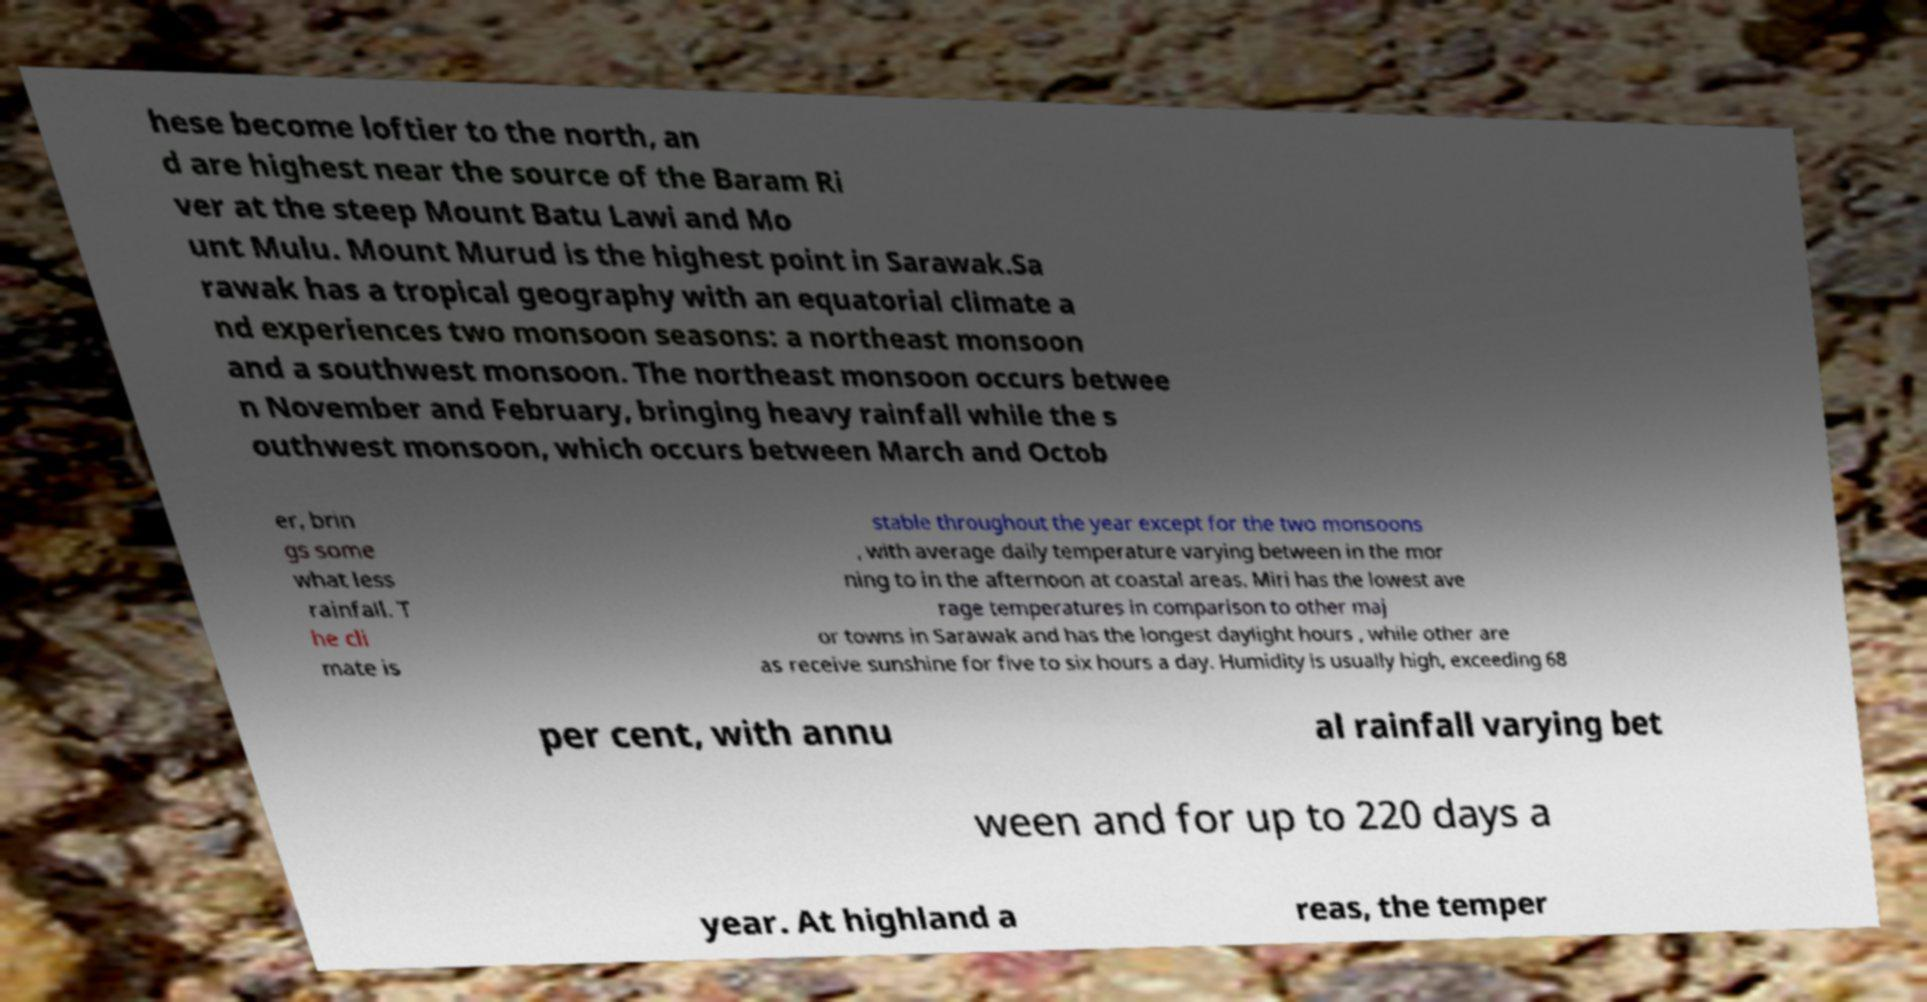Please identify and transcribe the text found in this image. hese become loftier to the north, an d are highest near the source of the Baram Ri ver at the steep Mount Batu Lawi and Mo unt Mulu. Mount Murud is the highest point in Sarawak.Sa rawak has a tropical geography with an equatorial climate a nd experiences two monsoon seasons: a northeast monsoon and a southwest monsoon. The northeast monsoon occurs betwee n November and February, bringing heavy rainfall while the s outhwest monsoon, which occurs between March and Octob er, brin gs some what less rainfall. T he cli mate is stable throughout the year except for the two monsoons , with average daily temperature varying between in the mor ning to in the afternoon at coastal areas. Miri has the lowest ave rage temperatures in comparison to other maj or towns in Sarawak and has the longest daylight hours , while other are as receive sunshine for five to six hours a day. Humidity is usually high, exceeding 68 per cent, with annu al rainfall varying bet ween and for up to 220 days a year. At highland a reas, the temper 